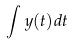<formula> <loc_0><loc_0><loc_500><loc_500>\int y ( t ) d t</formula> 